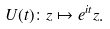<formula> <loc_0><loc_0><loc_500><loc_500>U ( t ) \colon z \mapsto e ^ { i t } z .</formula> 